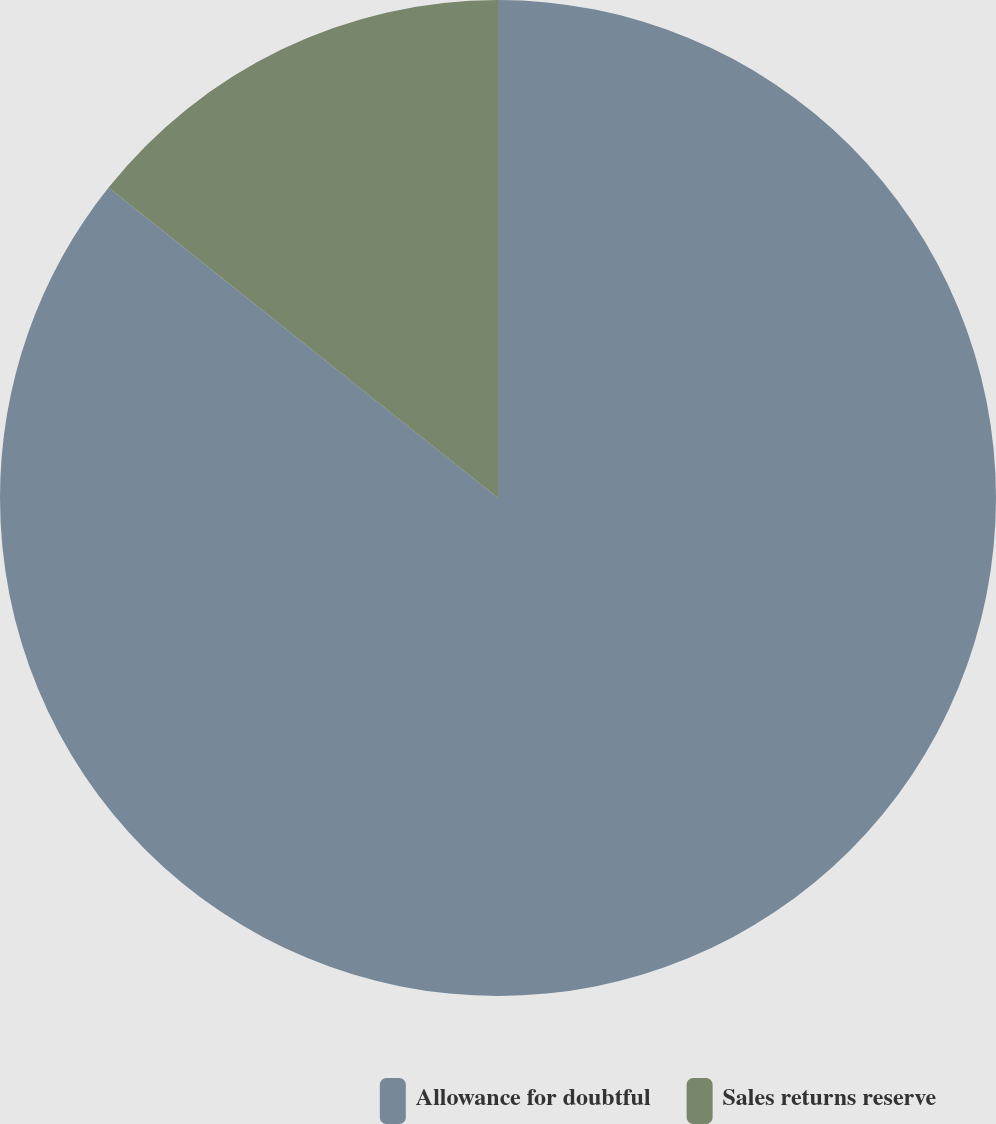Convert chart. <chart><loc_0><loc_0><loc_500><loc_500><pie_chart><fcel>Allowance for doubtful<fcel>Sales returns reserve<nl><fcel>85.71%<fcel>14.29%<nl></chart> 